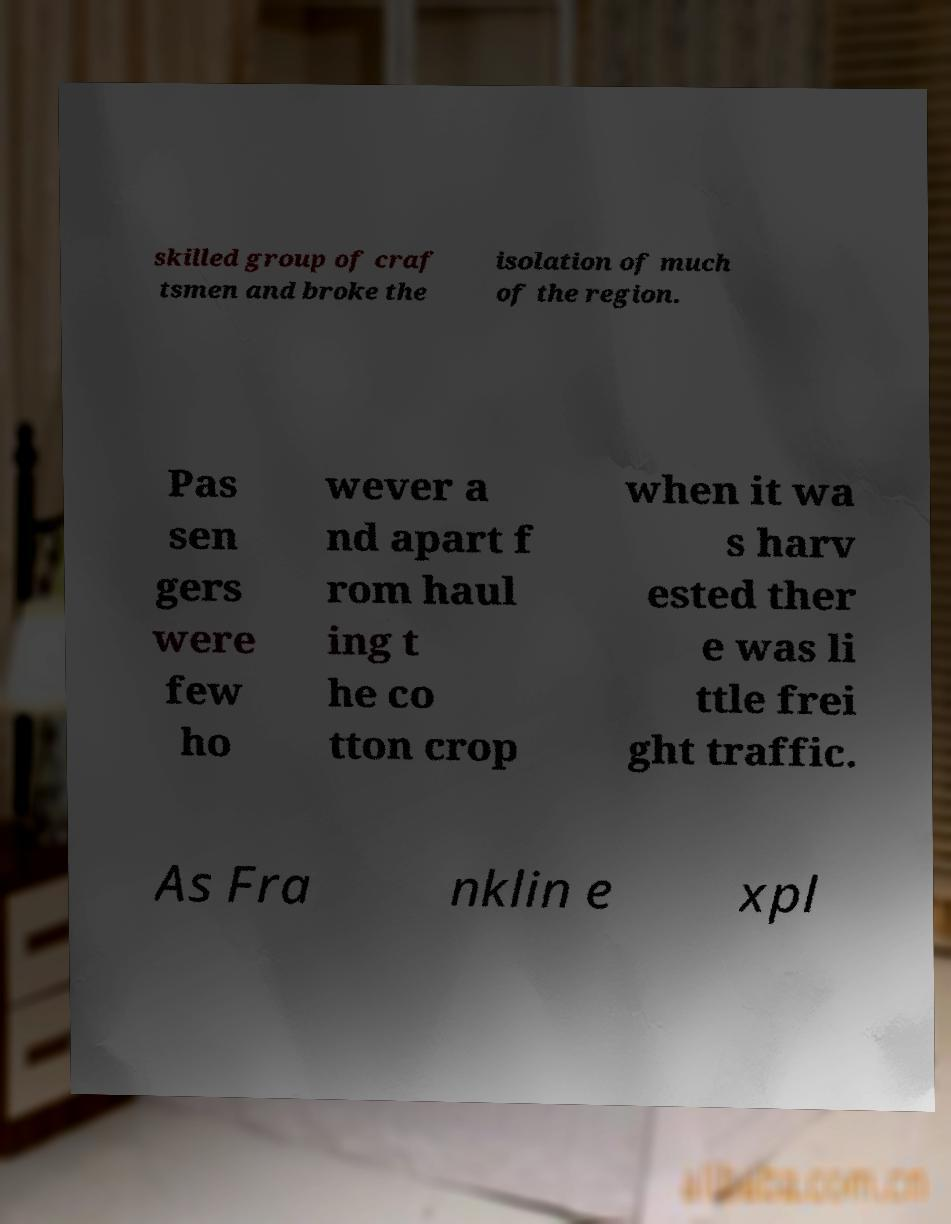I need the written content from this picture converted into text. Can you do that? skilled group of craf tsmen and broke the isolation of much of the region. Pas sen gers were few ho wever a nd apart f rom haul ing t he co tton crop when it wa s harv ested ther e was li ttle frei ght traffic. As Fra nklin e xpl 